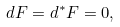<formula> <loc_0><loc_0><loc_500><loc_500>d F = d ^ { * } F = 0 ,</formula> 